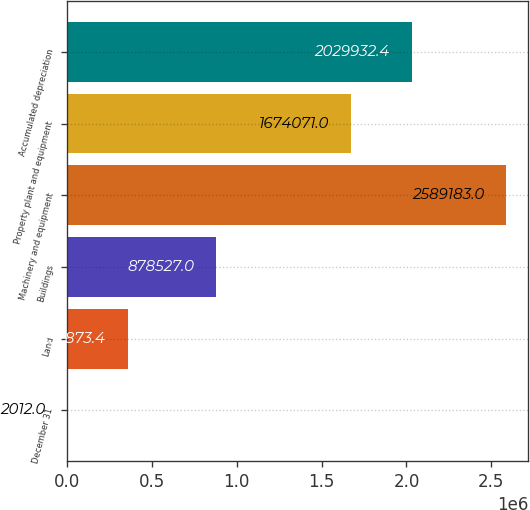Convert chart to OTSL. <chart><loc_0><loc_0><loc_500><loc_500><bar_chart><fcel>December 31<fcel>Land<fcel>Buildings<fcel>Machinery and equipment<fcel>Property plant and equipment<fcel>Accumulated depreciation<nl><fcel>2012<fcel>357873<fcel>878527<fcel>2.58918e+06<fcel>1.67407e+06<fcel>2.02993e+06<nl></chart> 